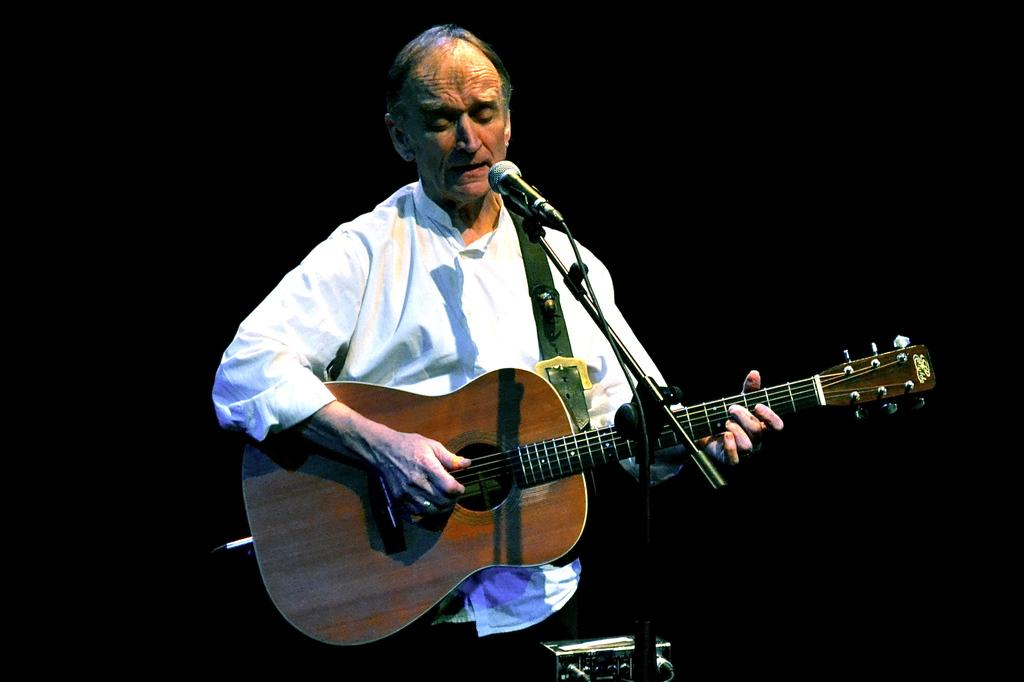What is the main subject of the image? There is a man in the image. What is the man doing in the image? The man is standing in the image. What object is the man holding in the image? The man is holding a guitar in the image. What object is in front of the man in the image? There is a microphone in front of the man in the image. What is the man wearing in the image? The man is wearing a white shirt in the image. What is the man's brother doing in the image? There is no mention of a brother in the image, so it cannot be determined what the brother might be doing. 